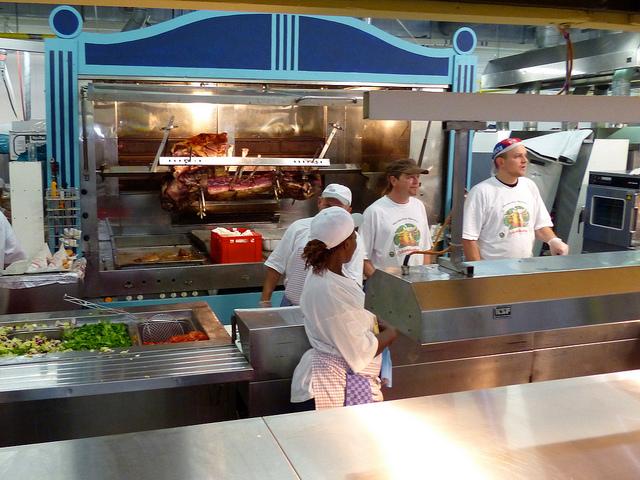Why are people standing?
Keep it brief. Cooking. What is roasting in the oven behind the people?
Be succinct. Meat. What is everyone wearing on their head?
Quick response, please. Hat. Is the chef in the picture?
Answer briefly. Yes. Does this appear to be a butcher shop?
Keep it brief. No. 